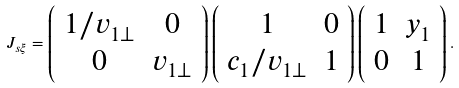Convert formula to latex. <formula><loc_0><loc_0><loc_500><loc_500>J _ { s \xi } = \left ( \begin{array} { c c } 1 / v _ { 1 \perp } & 0 \\ 0 & v _ { 1 \perp } \end{array} \right ) \left ( \begin{array} { c c } 1 & 0 \\ c _ { 1 } / v _ { 1 \perp } & 1 \end{array} \right ) \left ( \begin{array} { c c } 1 & y _ { 1 } \\ 0 & 1 \end{array} \right ) .</formula> 